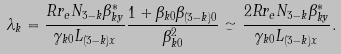<formula> <loc_0><loc_0><loc_500><loc_500>\lambda _ { k } = { \frac { R r _ { e } N _ { 3 - k } \beta _ { k y } ^ { \ast } } { \gamma _ { k 0 } L _ { ( 3 - k ) x } } } { \frac { 1 + \beta _ { k 0 } \beta _ { ( 3 - k ) 0 } } { \beta _ { k 0 } ^ { 2 } } } \simeq { \frac { 2 R r _ { e } N _ { 3 - k } \beta _ { k y } ^ { \ast } } { \gamma _ { k 0 } L _ { ( 3 - k ) x } } } .</formula> 